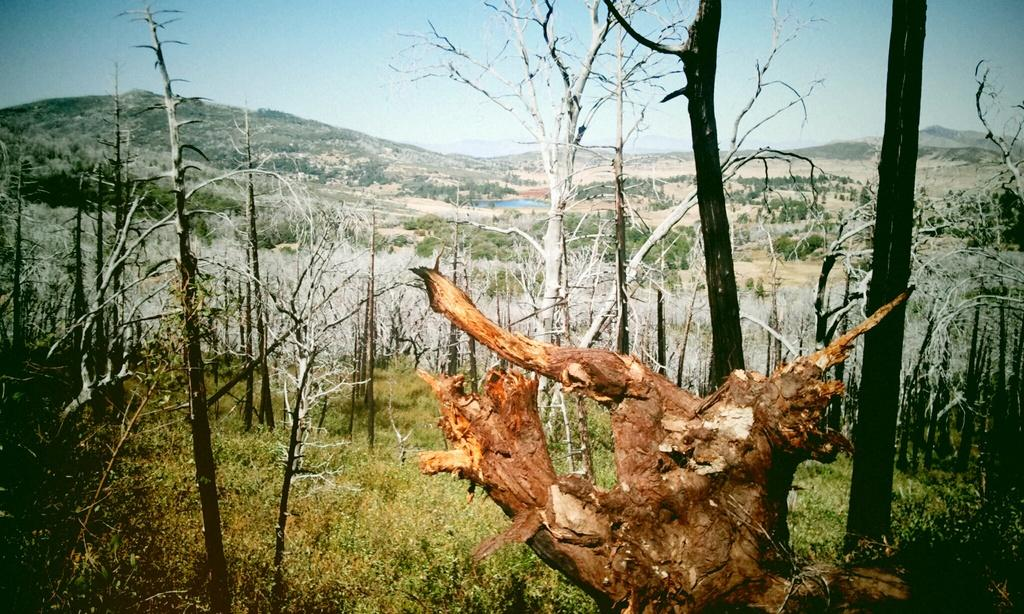What is the main object in the foreground of the image? There is a wooden log in the foreground of the image. What type of vegetation can be seen in the image? There are trees, plants, and grass in the image. What can be seen in the background of the image? There are trees, hills, a water body, and other objects in the background of the image. What type of copper material can be seen in the image? There is no copper material present in the image. What is the afterthought of the person who took the image? The image does not provide any information about the photographer's thoughts or intentions, so we cannot determine their afterthought. 